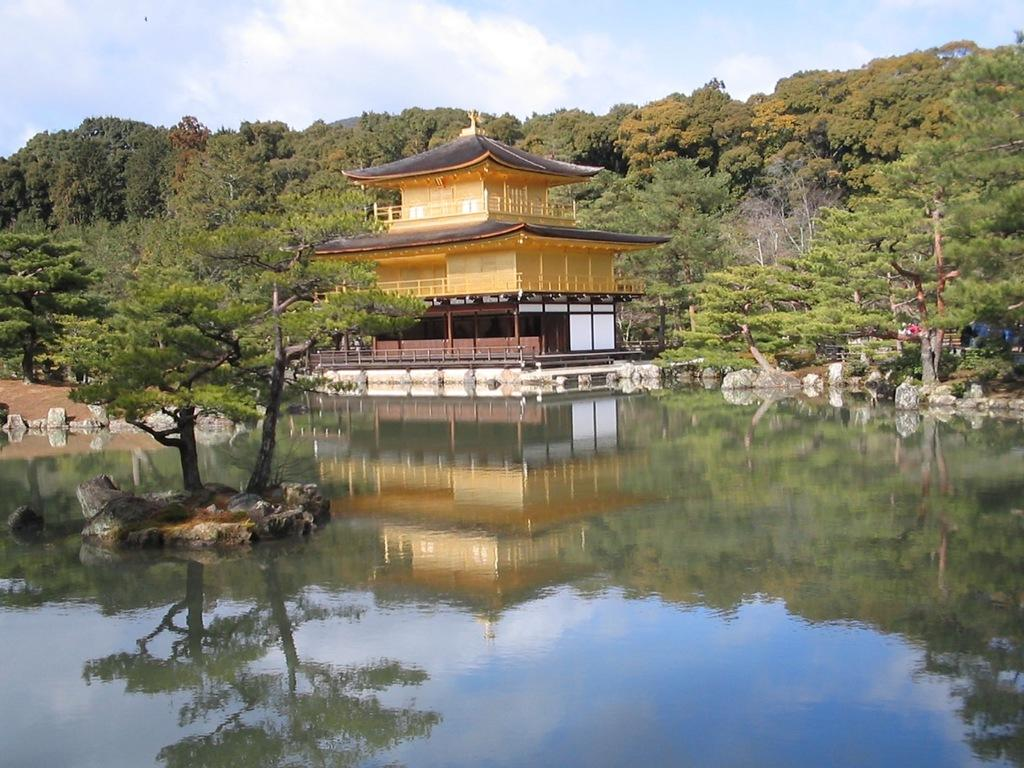What type of structure is visible in the image? There is a house in the image. What is present at the bottom of the image? There is water at the bottom of the image. What can be seen in the distance in the image? There are mountains and trees in the background of the image. What type of watch is the manager wearing in the image? There is no watch or manager present in the image. How does the umbrella protect the trees from the water in the image? There is no umbrella present in the image, and therefore it cannot protect the trees from the water. 